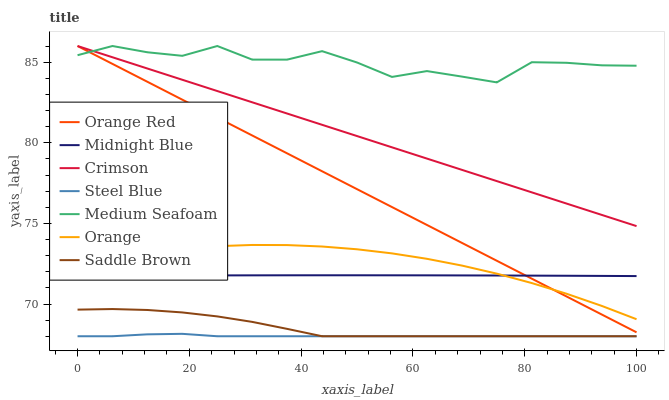Does Steel Blue have the minimum area under the curve?
Answer yes or no. Yes. Does Medium Seafoam have the maximum area under the curve?
Answer yes or no. Yes. Does Midnight Blue have the minimum area under the curve?
Answer yes or no. No. Does Midnight Blue have the maximum area under the curve?
Answer yes or no. No. Is Crimson the smoothest?
Answer yes or no. Yes. Is Medium Seafoam the roughest?
Answer yes or no. Yes. Is Midnight Blue the smoothest?
Answer yes or no. No. Is Midnight Blue the roughest?
Answer yes or no. No. Does Saddle Brown have the lowest value?
Answer yes or no. Yes. Does Midnight Blue have the lowest value?
Answer yes or no. No. Does Medium Seafoam have the highest value?
Answer yes or no. Yes. Does Midnight Blue have the highest value?
Answer yes or no. No. Is Steel Blue less than Crimson?
Answer yes or no. Yes. Is Orange greater than Saddle Brown?
Answer yes or no. Yes. Does Midnight Blue intersect Orange?
Answer yes or no. Yes. Is Midnight Blue less than Orange?
Answer yes or no. No. Is Midnight Blue greater than Orange?
Answer yes or no. No. Does Steel Blue intersect Crimson?
Answer yes or no. No. 